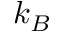Convert formula to latex. <formula><loc_0><loc_0><loc_500><loc_500>k _ { B }</formula> 